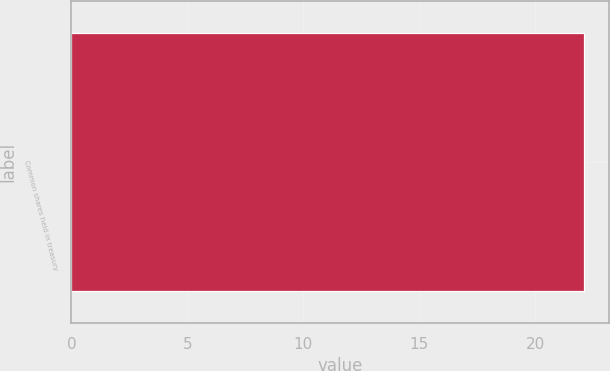<chart> <loc_0><loc_0><loc_500><loc_500><bar_chart><fcel>Common shares held in treasury<nl><fcel>22.1<nl></chart> 